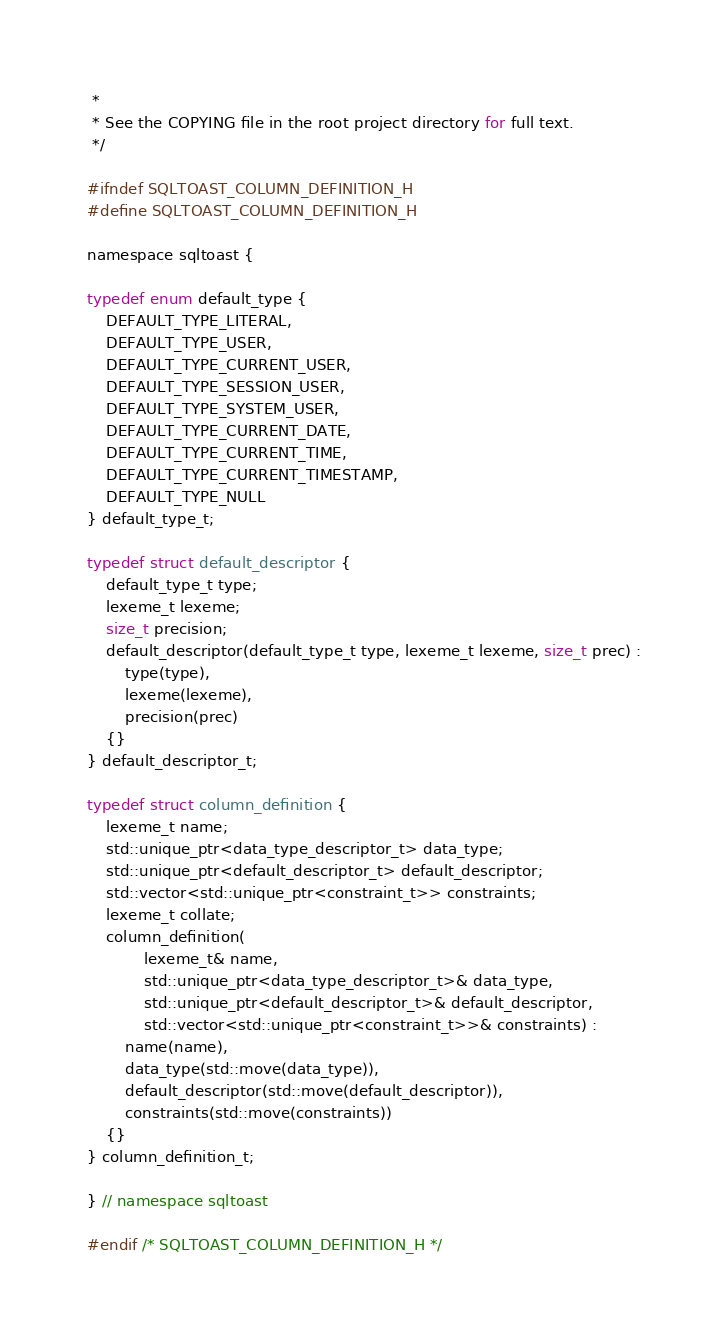Convert code to text. <code><loc_0><loc_0><loc_500><loc_500><_C_> *
 * See the COPYING file in the root project directory for full text.
 */

#ifndef SQLTOAST_COLUMN_DEFINITION_H
#define SQLTOAST_COLUMN_DEFINITION_H

namespace sqltoast {

typedef enum default_type {
    DEFAULT_TYPE_LITERAL,
    DEFAULT_TYPE_USER,
    DEFAULT_TYPE_CURRENT_USER,
    DEFAULT_TYPE_SESSION_USER,
    DEFAULT_TYPE_SYSTEM_USER,
    DEFAULT_TYPE_CURRENT_DATE,
    DEFAULT_TYPE_CURRENT_TIME,
    DEFAULT_TYPE_CURRENT_TIMESTAMP,
    DEFAULT_TYPE_NULL
} default_type_t;

typedef struct default_descriptor {
    default_type_t type;
    lexeme_t lexeme;
    size_t precision;
    default_descriptor(default_type_t type, lexeme_t lexeme, size_t prec) :
        type(type),
        lexeme(lexeme),
        precision(prec)
    {}
} default_descriptor_t;

typedef struct column_definition {
    lexeme_t name;
    std::unique_ptr<data_type_descriptor_t> data_type;
    std::unique_ptr<default_descriptor_t> default_descriptor;
    std::vector<std::unique_ptr<constraint_t>> constraints;
    lexeme_t collate;
    column_definition(
            lexeme_t& name,
            std::unique_ptr<data_type_descriptor_t>& data_type,
            std::unique_ptr<default_descriptor_t>& default_descriptor,
            std::vector<std::unique_ptr<constraint_t>>& constraints) :
        name(name),
        data_type(std::move(data_type)),
        default_descriptor(std::move(default_descriptor)),
        constraints(std::move(constraints))
    {}
} column_definition_t;

} // namespace sqltoast

#endif /* SQLTOAST_COLUMN_DEFINITION_H */
</code> 